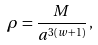Convert formula to latex. <formula><loc_0><loc_0><loc_500><loc_500>\rho = \frac { M } { a ^ { 3 ( w + 1 ) } } \, ,</formula> 